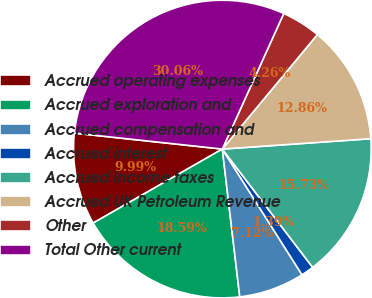<chart> <loc_0><loc_0><loc_500><loc_500><pie_chart><fcel>Accrued operating expenses<fcel>Accrued exploration and<fcel>Accrued compensation and<fcel>Accrued interest<fcel>Accrued income taxes<fcel>Accrued UK Petroleum Revenue<fcel>Other<fcel>Total Other current<nl><fcel>9.99%<fcel>18.59%<fcel>7.12%<fcel>1.39%<fcel>15.73%<fcel>12.86%<fcel>4.26%<fcel>30.06%<nl></chart> 